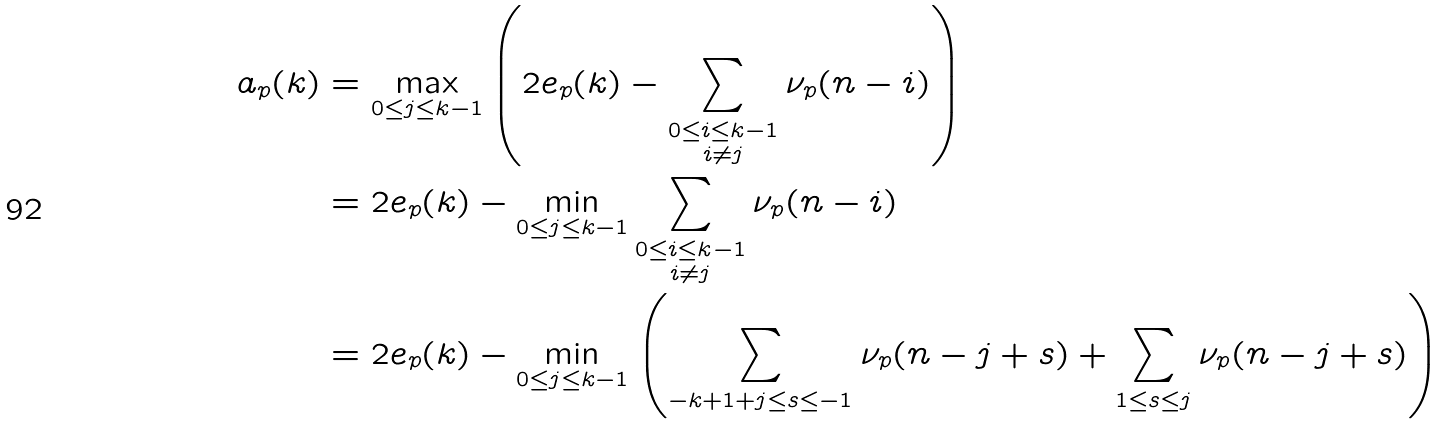Convert formula to latex. <formula><loc_0><loc_0><loc_500><loc_500>a _ { p } ( k ) & = \max _ { 0 \leq j \leq k - 1 } \left ( 2 e _ { p } ( k ) - \sum _ { \substack { 0 \leq i \leq k - 1 \\ i \neq j } } \nu _ { p } ( n - i ) \right ) \\ & = 2 e _ { p } ( k ) - \min _ { 0 \leq j \leq k - 1 } \sum _ { \substack { 0 \leq i \leq k - 1 \\ i \neq j } } \nu _ { p } ( n - i ) \\ & = 2 e _ { p } ( k ) - \min _ { 0 \leq j \leq k - 1 } \left ( \sum _ { - k + 1 + j \leq s \leq - 1 } \nu _ { p } ( n - j + s ) + \sum _ { 1 \leq s \leq j } \nu _ { p } ( n - j + s ) \right ) \\</formula> 